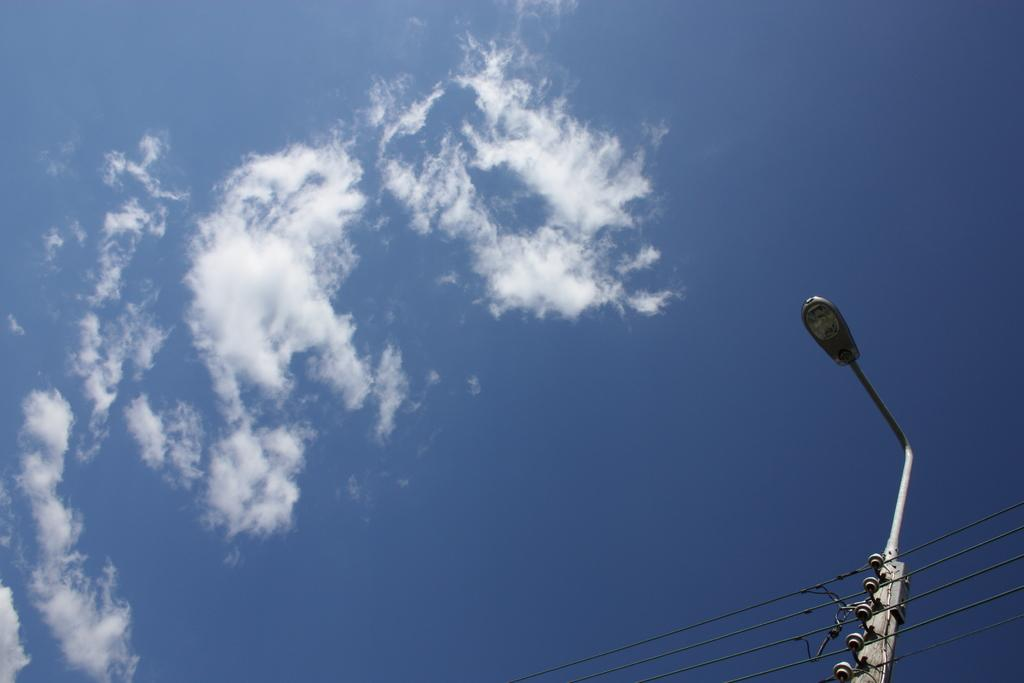What structure is located on the left side of the image? There is a street light on the left side of the image. What is visible in the background of the image? The sky is visible in the image. What can be seen in the sky? Clouds are present in the sky. Where is the pin located on the desk in the image? There is no desk or pin present in the image. What type of music can be heard playing in the background of the image? There is no music present in the image. 